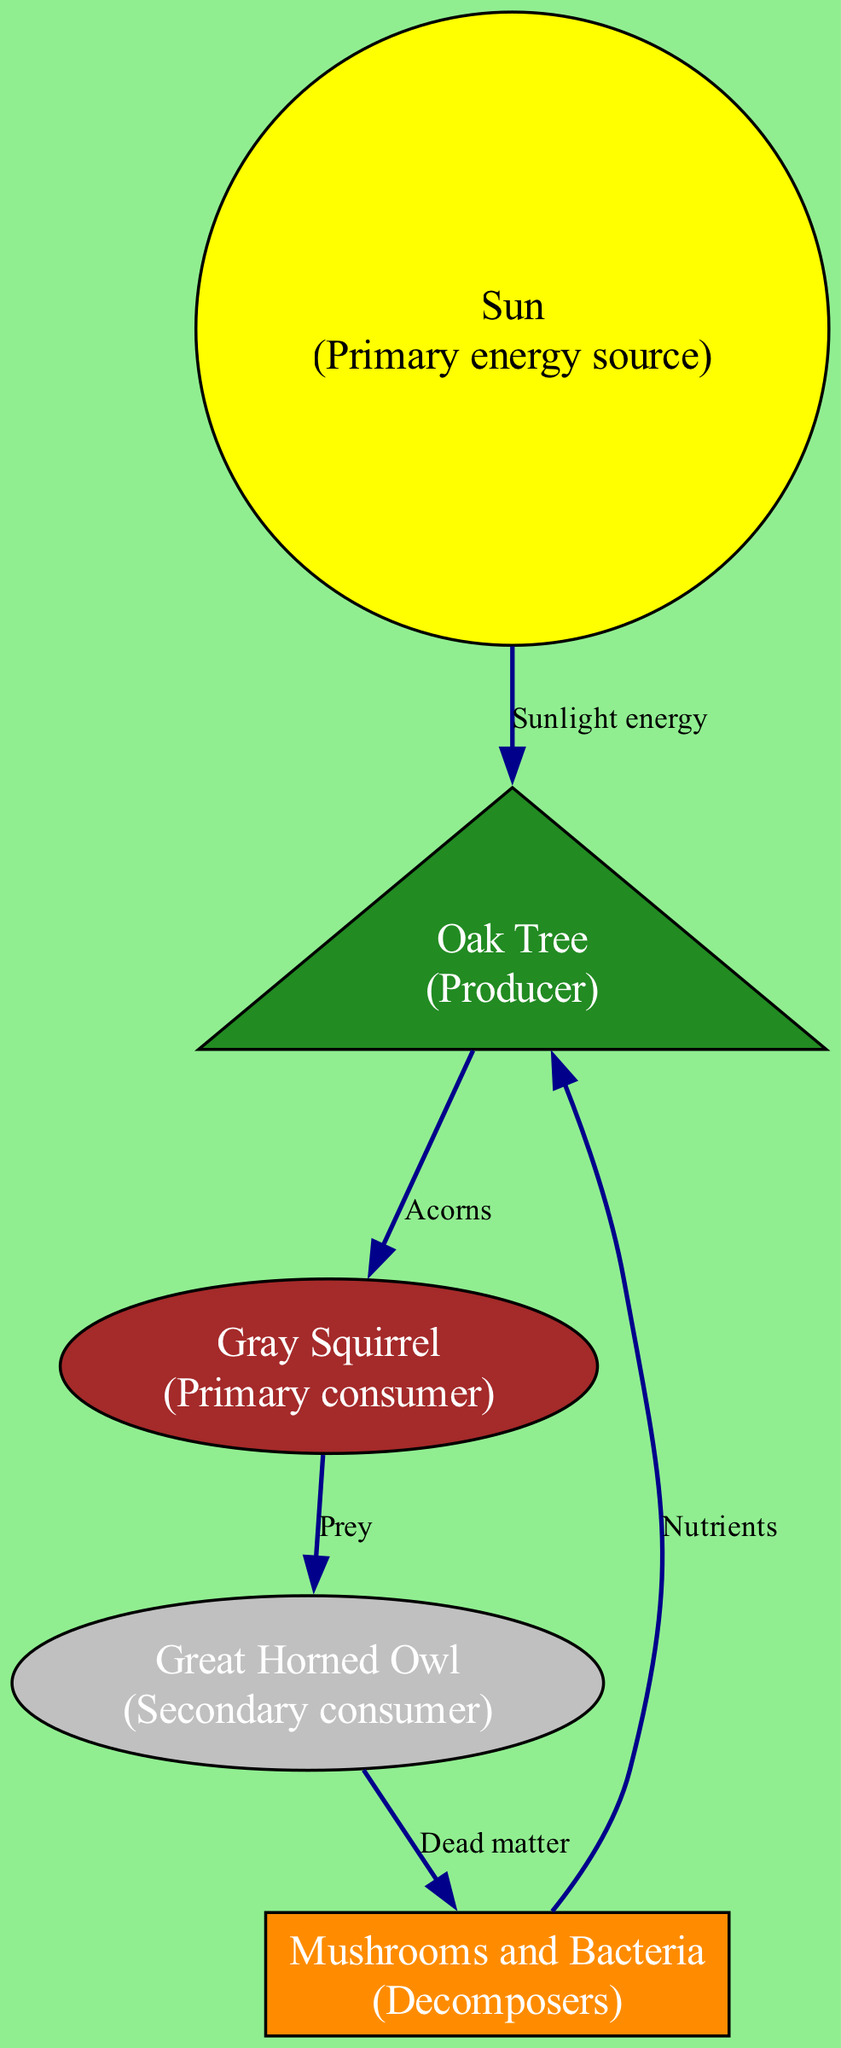What is the primary energy source in the diagram? The diagram shows the "Sun" as a node labeled as the primary energy source, indicating that it provides the necessary energy for the forest ecosystem.
Answer: Sun How many nodes are present in the diagram? By counting the nodes listed, there are five nodes: Sun, Oak Tree, Gray Squirrel, Great Horned Owl, and Mushrooms and Bacteria.
Answer: 5 Which organism is the primary consumer in this ecosystem? The Gray Squirrel is labeled as the primary consumer, which means it feeds on the Oak Tree.
Answer: Gray Squirrel What do decomposers recycle back to the ecosystem? According to the diagram, decomposers (Mushrooms and Bacteria) recycle nutrients back to the Oak Tree, which is a key part of nutrient cycling in the ecosystem.
Answer: Nutrients What relationship does the Oak Tree have with the Sun? The diagram directly connects the Sun to the Oak Tree with the label "Sunlight energy," indicating that the tree utilizes sunlight to produce energy through photosynthesis.
Answer: Sunlight energy What is the prey of the Great Horned Owl? The diagram illustrates that the Great Horned Owl preys on the Gray Squirrel, signifying the predator-prey relationship between these two organisms.
Answer: Prey How do decomposers contribute to the food chain? Decomposers in the diagram break down dead matter from the Great Horned Owl, returning important nutrients back to the soil, which supports the growth of producers like the Oak Tree.
Answer: Nutrients Who directly depends on the Oak Tree for food? The Gray Squirrel depends on the Oak Tree for food, as indicated by the edge labeled "Acorns" connecting the two nodes.
Answer: Gray Squirrel What process is represented by the edge labeled "Dead matter"? The edge labeled "Dead matter" signifies the relationship where the Great Horned Owl, upon death, provides matter for the decomposers to break down and recycle nutrients back into the ecosystem.
Answer: Dead matter 